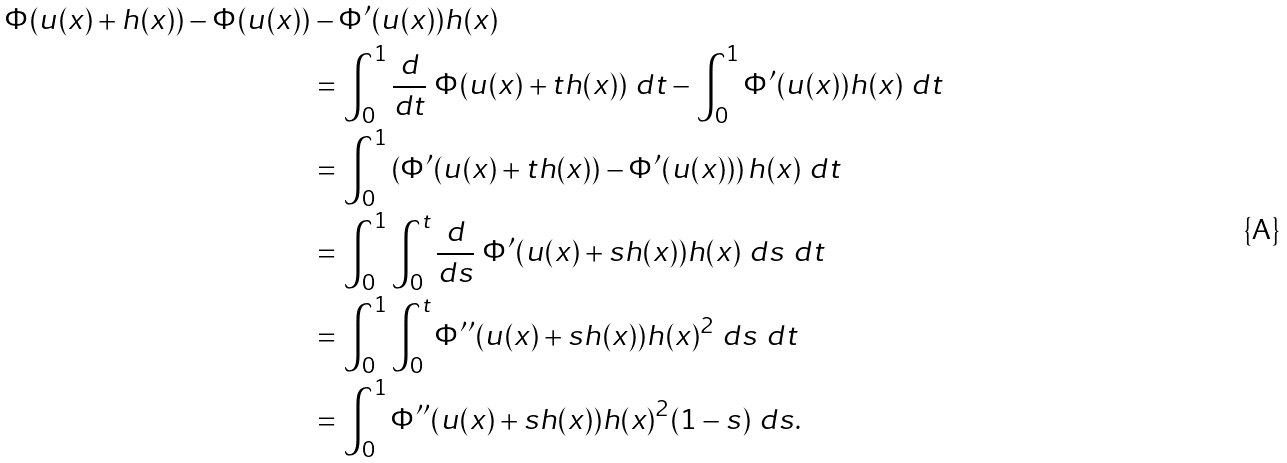<formula> <loc_0><loc_0><loc_500><loc_500>\Phi ( u ( x ) + h ( x ) ) - \Phi ( u ( x ) ) & - \Phi ^ { \prime } ( u ( x ) ) h ( x ) \\ & = \int _ { 0 } ^ { 1 } \frac { d } { d t } \ \Phi ( u ( x ) + t h ( x ) ) \ d t - \int _ { 0 } ^ { 1 } \Phi ^ { \prime } ( u ( x ) ) h ( x ) \ d t \\ & = \int _ { 0 } ^ { 1 } \left ( \Phi ^ { \prime } ( u ( x ) + t h ( x ) ) - \Phi ^ { \prime } ( u ( x ) ) \right ) h ( x ) \ d t \\ & = \int _ { 0 } ^ { 1 } \int _ { 0 } ^ { t } \frac { d } { d s } \ \Phi ^ { \prime } ( u ( x ) + s h ( x ) ) h ( x ) \ d s \ d t \\ & = \int _ { 0 } ^ { 1 } \int _ { 0 } ^ { t } \Phi ^ { \prime \prime } ( u ( x ) + s h ( x ) ) h ( x ) ^ { 2 } \ d s \ d t \\ & = \int _ { 0 } ^ { 1 } \Phi ^ { \prime \prime } ( u ( x ) + s h ( x ) ) h ( x ) ^ { 2 } ( 1 - s ) \ d s .</formula> 